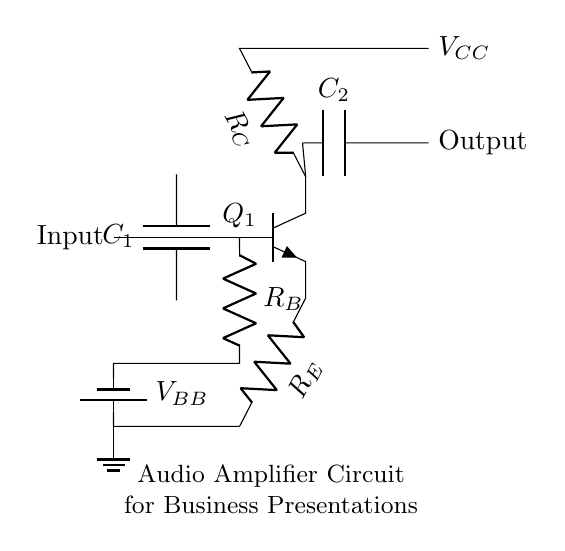What is the total number of capacitors in this circuit? There are two capacitors labeled as C1 and C2 within the circuit diagram, indicating their presence in the audio amplifier setup.
Answer: 2 What type of transistor is used in this circuit? The circuit diagram shows an npn transistor labeled Q1, which can be identified by its symbol and designation in the diagram.
Answer: npn What is the voltage source connected to the collector of the transistor? The circuit has a voltage source indicated as VCC, connected to the collector of the transistor through a resistor RC. This shows how the transistor receives power.
Answer: VCC What are the names of the resistors in the circuit? The circuit contains three resistors labeled as RC (collector resistor), RB (base resistor), and RE (emitter resistor). All these labels are provided directly in the circuit diagram.
Answer: RC, RB, RE What is the function of capacitor C1 in the circuit? Capacitor C1 acts as a coupling capacitor that blocks DC voltage and allows AC signals to pass through to the base of the transistor. This is essential for audio signals in amplifier circuits.
Answer: Coupling capacitor What is the significance of the ground connection in this circuit? The ground provides a common reference point for the entire circuit, ensuring stable operation and proper functioning of the amplifier by completing the circuit path for currents.
Answer: Common reference What is the output of the audio amplifier connected to? The output as shown in the circuit diagram goes to a point labeled Output, indicating it would typically connect to an external device such as speakers or other audio systems for sound amplification.
Answer: Output 